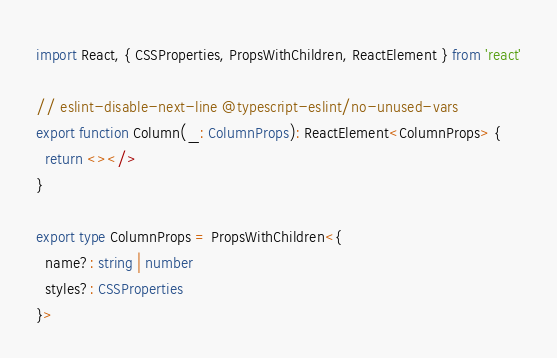Convert code to text. <code><loc_0><loc_0><loc_500><loc_500><_TypeScript_>import React, { CSSProperties, PropsWithChildren, ReactElement } from 'react'

// eslint-disable-next-line @typescript-eslint/no-unused-vars
export function Column(_: ColumnProps): ReactElement<ColumnProps> {
  return <></>
}

export type ColumnProps = PropsWithChildren<{
  name?: string | number
  styles?: CSSProperties
}>
</code> 